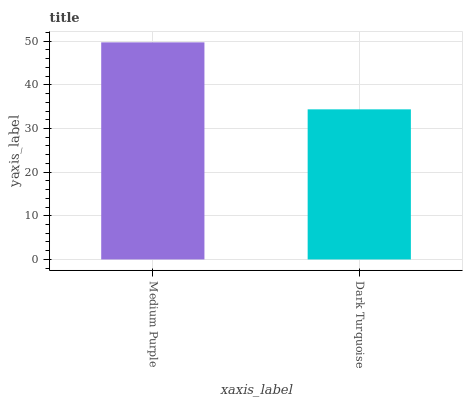Is Dark Turquoise the minimum?
Answer yes or no. Yes. Is Medium Purple the maximum?
Answer yes or no. Yes. Is Dark Turquoise the maximum?
Answer yes or no. No. Is Medium Purple greater than Dark Turquoise?
Answer yes or no. Yes. Is Dark Turquoise less than Medium Purple?
Answer yes or no. Yes. Is Dark Turquoise greater than Medium Purple?
Answer yes or no. No. Is Medium Purple less than Dark Turquoise?
Answer yes or no. No. Is Medium Purple the high median?
Answer yes or no. Yes. Is Dark Turquoise the low median?
Answer yes or no. Yes. Is Dark Turquoise the high median?
Answer yes or no. No. Is Medium Purple the low median?
Answer yes or no. No. 